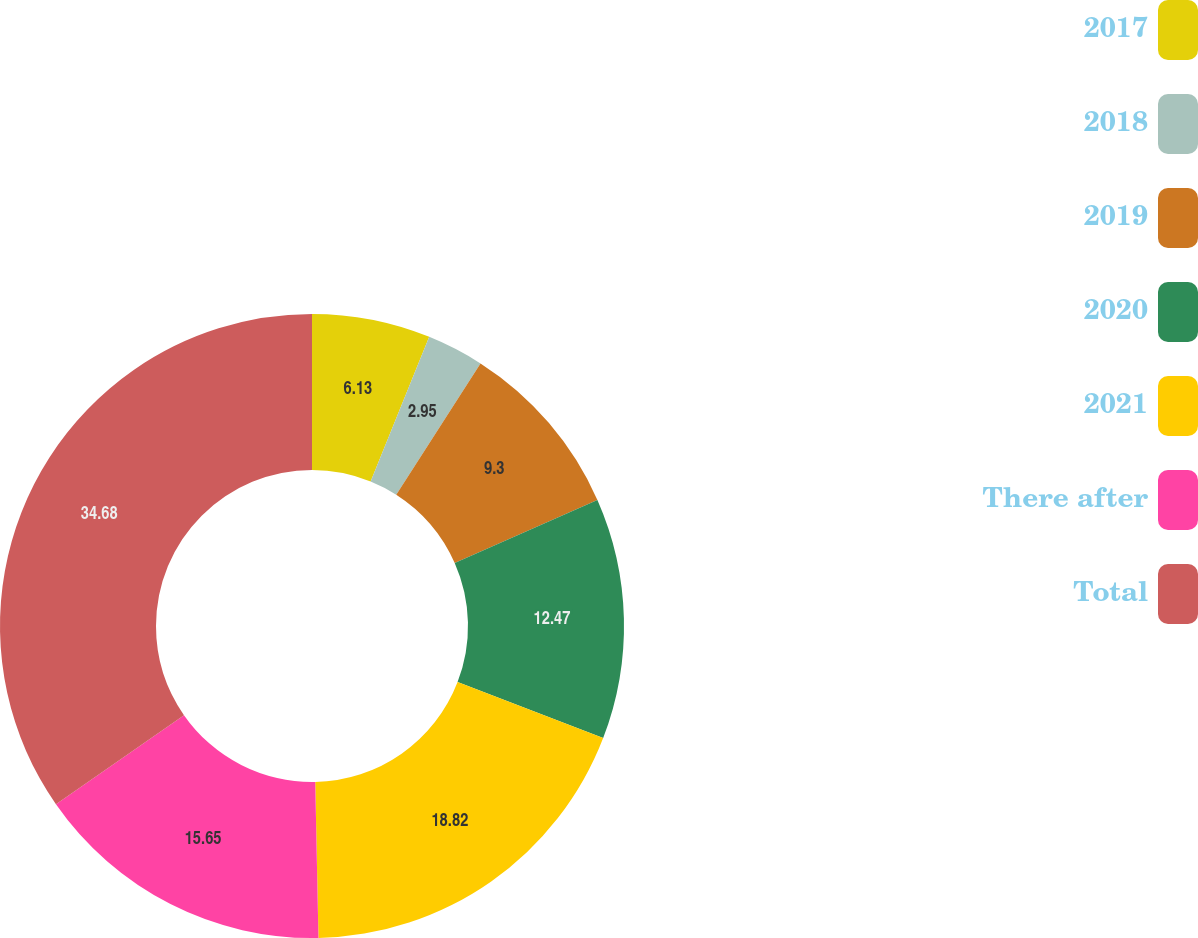Convert chart. <chart><loc_0><loc_0><loc_500><loc_500><pie_chart><fcel>2017<fcel>2018<fcel>2019<fcel>2020<fcel>2021<fcel>There after<fcel>Total<nl><fcel>6.13%<fcel>2.95%<fcel>9.3%<fcel>12.47%<fcel>18.82%<fcel>15.65%<fcel>34.68%<nl></chart> 